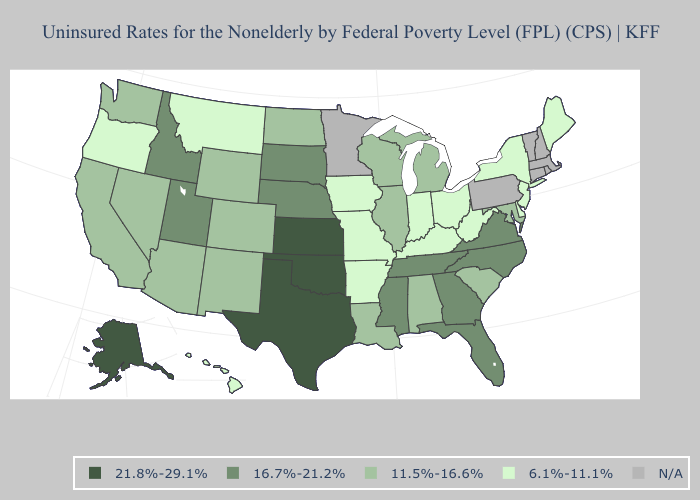What is the value of Massachusetts?
Concise answer only. N/A. Does Georgia have the lowest value in the USA?
Keep it brief. No. What is the value of Kentucky?
Short answer required. 6.1%-11.1%. Name the states that have a value in the range 16.7%-21.2%?
Keep it brief. Florida, Georgia, Idaho, Mississippi, Nebraska, North Carolina, South Dakota, Tennessee, Utah, Virginia. Does Florida have the highest value in the South?
Keep it brief. No. Among the states that border Washington , does Oregon have the highest value?
Answer briefly. No. Does West Virginia have the lowest value in the USA?
Write a very short answer. Yes. Which states have the lowest value in the USA?
Give a very brief answer. Arkansas, Delaware, Hawaii, Indiana, Iowa, Kentucky, Maine, Missouri, Montana, New Jersey, New York, Ohio, Oregon, West Virginia. What is the value of Nebraska?
Answer briefly. 16.7%-21.2%. What is the value of Indiana?
Be succinct. 6.1%-11.1%. Among the states that border Wyoming , which have the highest value?
Concise answer only. Idaho, Nebraska, South Dakota, Utah. Does South Dakota have the lowest value in the MidWest?
Concise answer only. No. Name the states that have a value in the range 11.5%-16.6%?
Give a very brief answer. Alabama, Arizona, California, Colorado, Illinois, Louisiana, Maryland, Michigan, Nevada, New Mexico, North Dakota, South Carolina, Washington, Wisconsin, Wyoming. What is the value of Colorado?
Give a very brief answer. 11.5%-16.6%. Among the states that border Arizona , which have the lowest value?
Write a very short answer. California, Colorado, Nevada, New Mexico. 